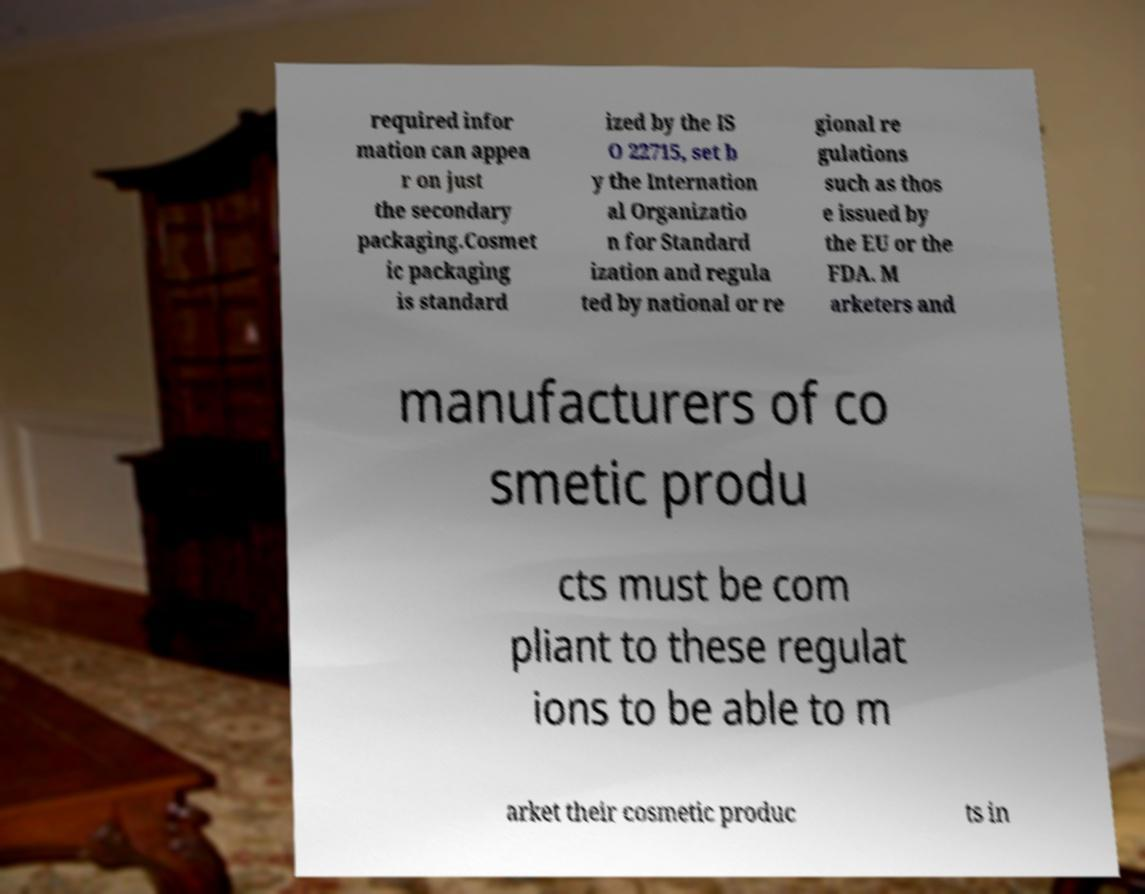Could you assist in decoding the text presented in this image and type it out clearly? required infor mation can appea r on just the secondary packaging.Cosmet ic packaging is standard ized by the IS O 22715, set b y the Internation al Organizatio n for Standard ization and regula ted by national or re gional re gulations such as thos e issued by the EU or the FDA. M arketers and manufacturers of co smetic produ cts must be com pliant to these regulat ions to be able to m arket their cosmetic produc ts in 